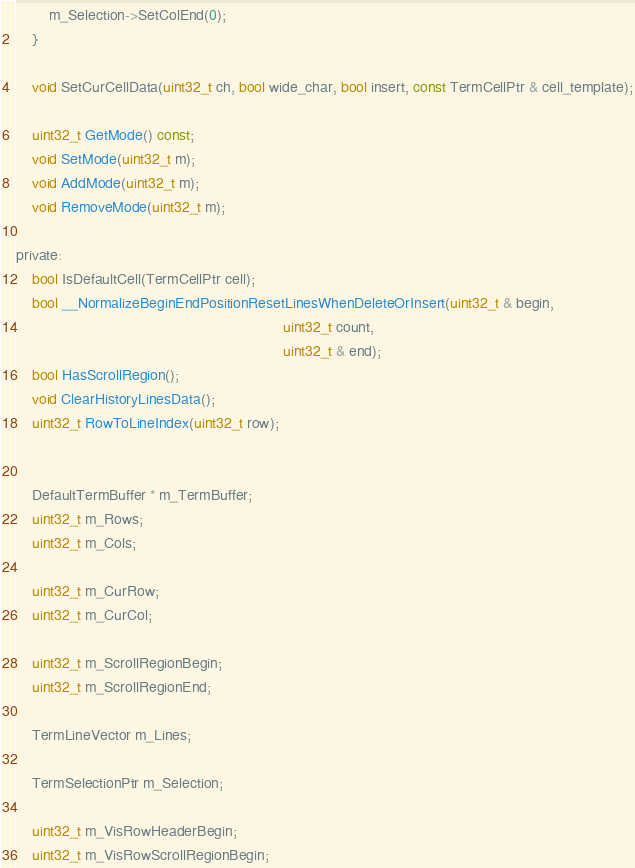Convert code to text. <code><loc_0><loc_0><loc_500><loc_500><_C_>        m_Selection->SetColEnd(0);
    }

    void SetCurCellData(uint32_t ch, bool wide_char, bool insert, const TermCellPtr & cell_template);

    uint32_t GetMode() const;
    void SetMode(uint32_t m);
    void AddMode(uint32_t m);
    void RemoveMode(uint32_t m);

private:
    bool IsDefaultCell(TermCellPtr cell);
    bool __NormalizeBeginEndPositionResetLinesWhenDeleteOrInsert(uint32_t & begin,
                                                                 uint32_t count,
                                                                 uint32_t & end);
    bool HasScrollRegion();
    void ClearHistoryLinesData();
    uint32_t RowToLineIndex(uint32_t row);


    DefaultTermBuffer * m_TermBuffer;
    uint32_t m_Rows;
    uint32_t m_Cols;

    uint32_t m_CurRow;
    uint32_t m_CurCol;

    uint32_t m_ScrollRegionBegin;
    uint32_t m_ScrollRegionEnd;

    TermLineVector m_Lines;

    TermSelectionPtr m_Selection;

    uint32_t m_VisRowHeaderBegin;
    uint32_t m_VisRowScrollRegionBegin;</code> 